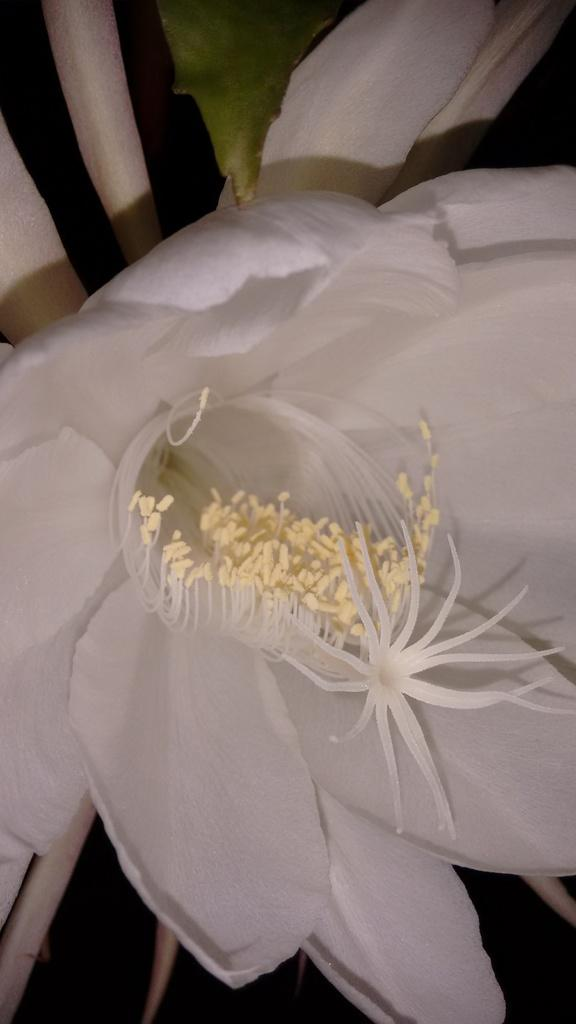What is the main subject in the center of the image? There is a white color object in the center of the image, which appears to be flowers. What is the color of the object in the background of the image? There is a green color object in the background of the image, which appears to be leaves. What type of punishment is being given to the flowers in the image? There is no punishment being given to the flowers in the image; it is a still image of flowers and leaves. What form does the hot object take in the image? There is no hot object present in the image; it features flowers and leaves. 